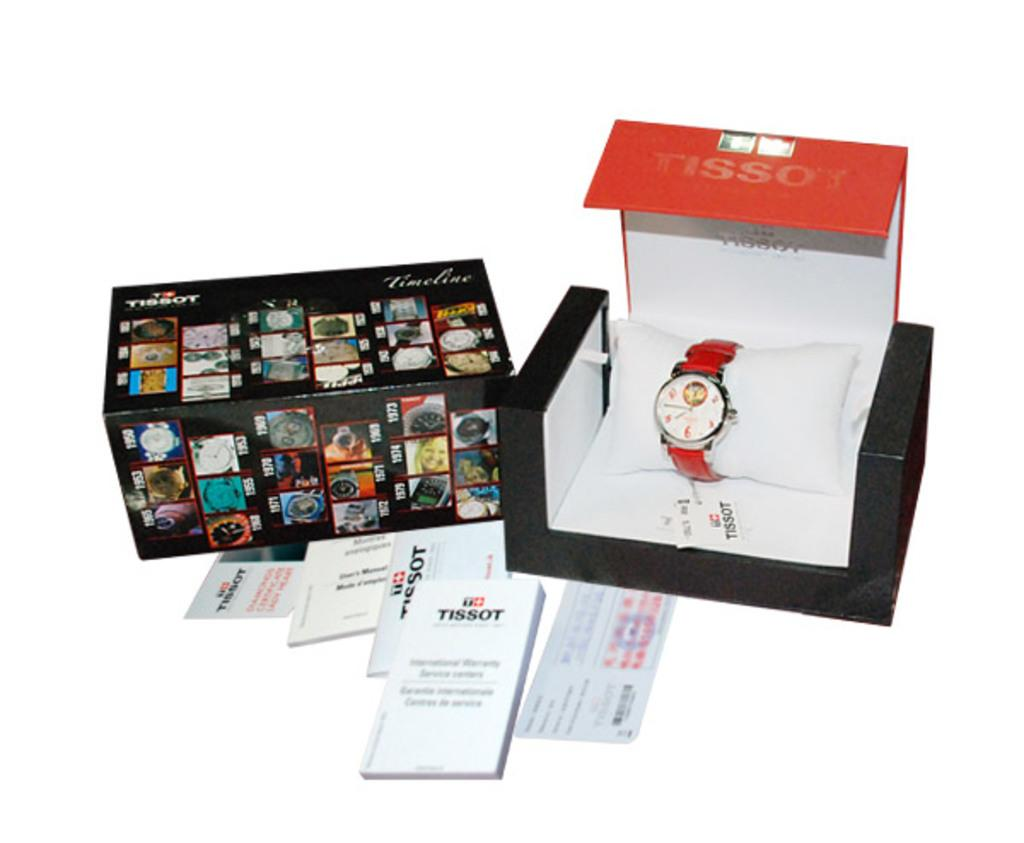<image>
Render a clear and concise summary of the photo. The display packaging of a Tissot brand watch with a white face, silver bezel and red leather band. 